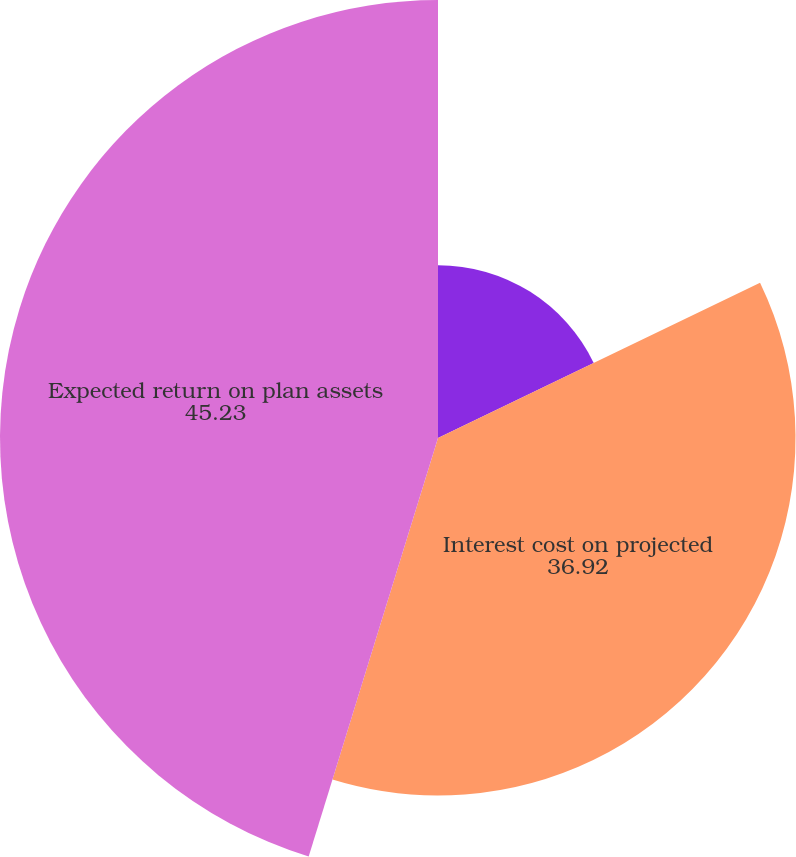Convert chart to OTSL. <chart><loc_0><loc_0><loc_500><loc_500><pie_chart><fcel>Service cost - benefits earned<fcel>Interest cost on projected<fcel>Expected return on plan assets<nl><fcel>17.85%<fcel>36.92%<fcel>45.23%<nl></chart> 